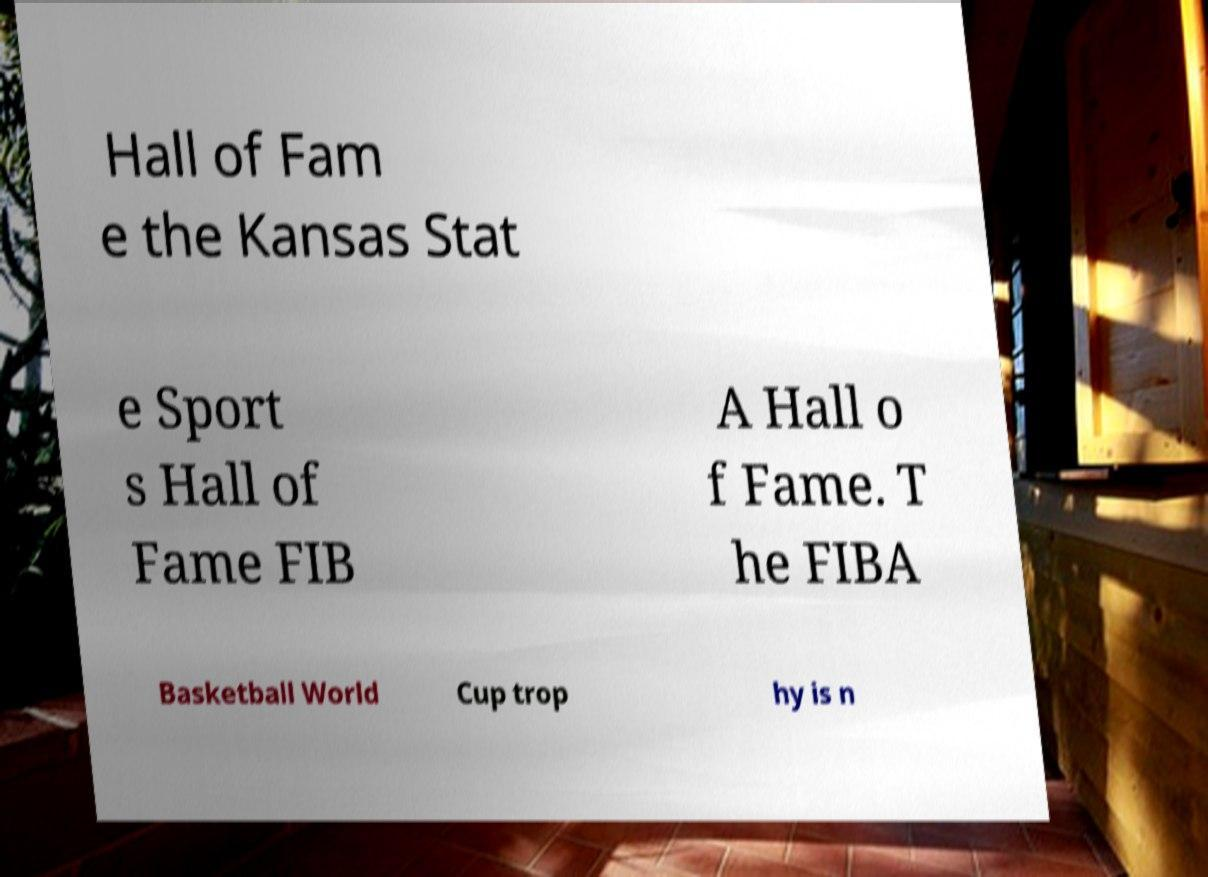Could you extract and type out the text from this image? Hall of Fam e the Kansas Stat e Sport s Hall of Fame FIB A Hall o f Fame. T he FIBA Basketball World Cup trop hy is n 